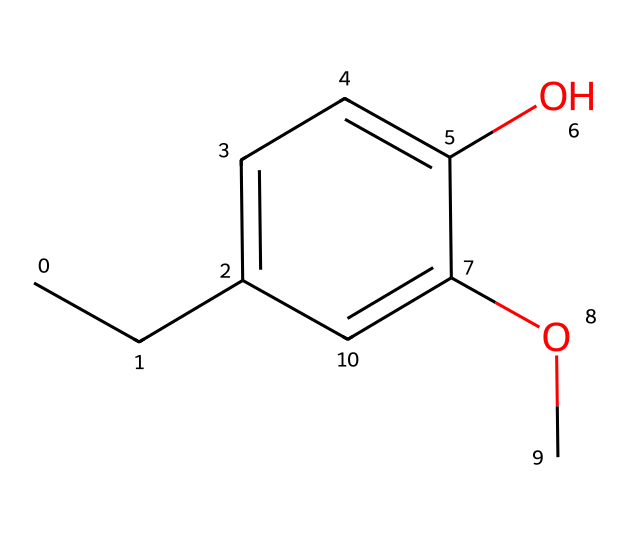What is the name of this aromatic compound? The SMILES representation indicates the presence of a chemical structure which matches the known structure of eugenol, commonly associated with clove oil and its scent.
Answer: eugenol How many oxygen atoms are present in this structure? By analyzing the provided SMILES, we find two oxygen atoms indicated by the presence of "O" in the formula, one from the hydroxyl group and the other from the methoxy group.
Answer: 2 What is the degree of saturation of this compound? To determine the degree of saturation, we count the number of double bonds and rings. This structure shows no double bonds (the aromatic ring counts as one). Thus, it is fully saturated with one aromatic ring and does not have any additional unsaturation.
Answer: 1 Does this compound have a methoxy group? In the SMILES, the "OC" shows a methoxy group (-OCH3) part of the structure, indicating the presence of a methoxy substituent.
Answer: yes What type of functional groups are present in eugenol? The functional groups in this structure include a hydroxyl group (-OH) and a methoxy group (-OCH3). These specific groups contribute to the properties of the compound.
Answer: hydroxyl and methoxy Is this compound a strong base? By analyzing the structure, the presence of the hydroxyl group suggests it can act as a weak base (not a strong base), as it can donate a hydrogen ion only under certain conditions.
Answer: no How does the presence of the aromatic ring affect the solubility of eugenol? The aromatic ring typically makes compounds less polar, thereby reducing solubility in polar solvents. However, the hydroxyl and methoxy groups increase hydrogen bonding potential, which can improve solubility in certain contexts.
Answer: lowers solubility in water 